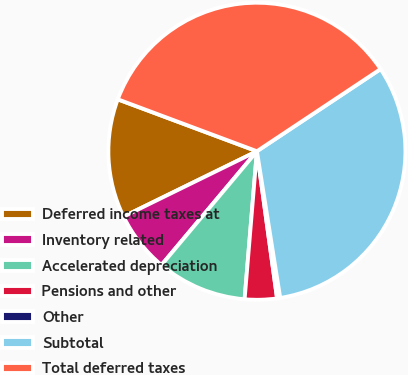Convert chart. <chart><loc_0><loc_0><loc_500><loc_500><pie_chart><fcel>Deferred income taxes at<fcel>Inventory related<fcel>Accelerated depreciation<fcel>Pensions and other<fcel>Other<fcel>Subtotal<fcel>Total deferred taxes<nl><fcel>12.94%<fcel>6.64%<fcel>9.79%<fcel>3.49%<fcel>0.34%<fcel>31.83%<fcel>34.98%<nl></chart> 